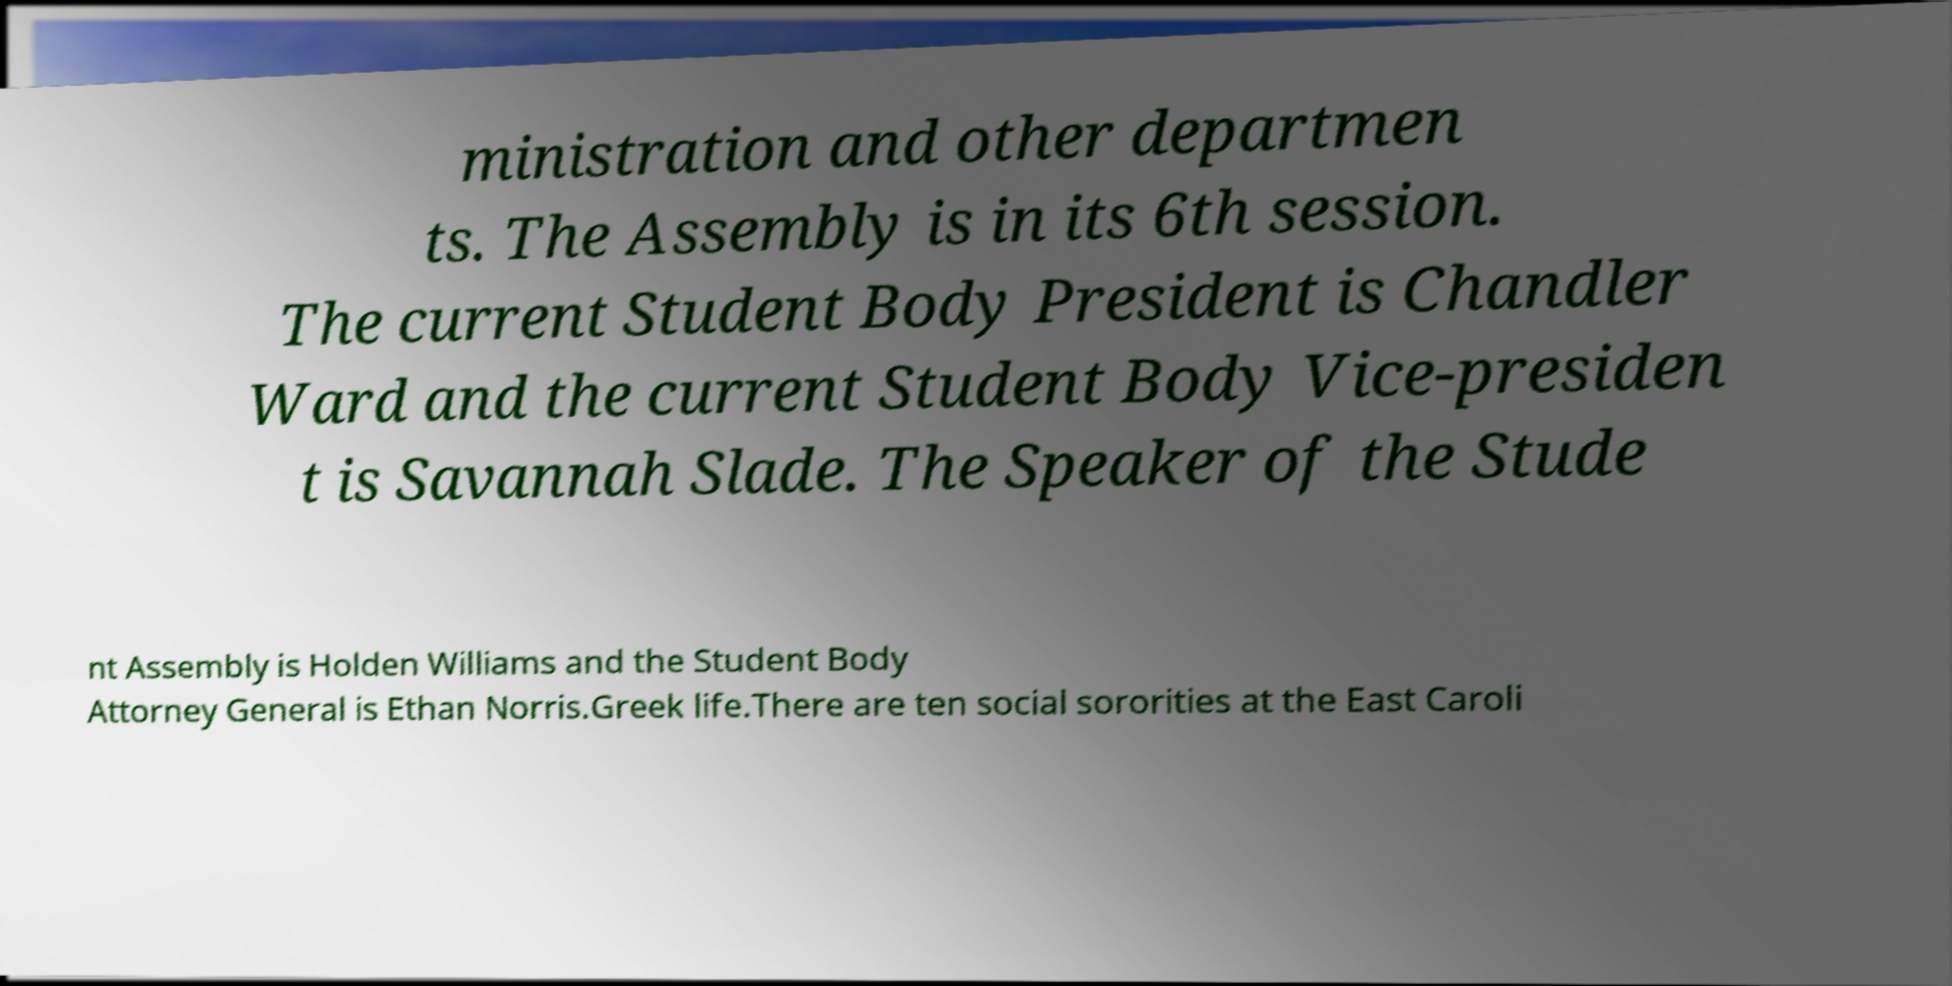For documentation purposes, I need the text within this image transcribed. Could you provide that? ministration and other departmen ts. The Assembly is in its 6th session. The current Student Body President is Chandler Ward and the current Student Body Vice-presiden t is Savannah Slade. The Speaker of the Stude nt Assembly is Holden Williams and the Student Body Attorney General is Ethan Norris.Greek life.There are ten social sororities at the East Caroli 